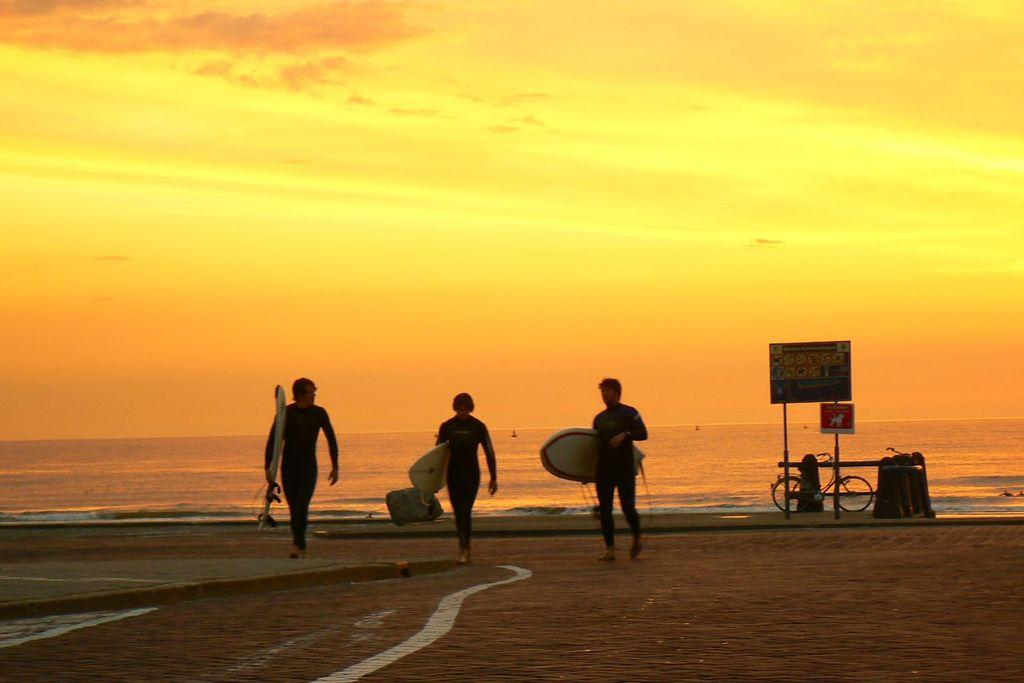How many people are in the image? There are three persons in the image. What are the persons carrying in the image? The persons are carrying surfboards. What are the persons doing in the image? The persons are walking. What can be seen in the background of the image? Sky, water, a cycle, and a board are visible in the background of the image. How many sons does the person in the middle have, according to the image? There is no information about sons or family relationships in the image. How many spiders are crawling on the surfboards in the image? There are no spiders present in the image. 